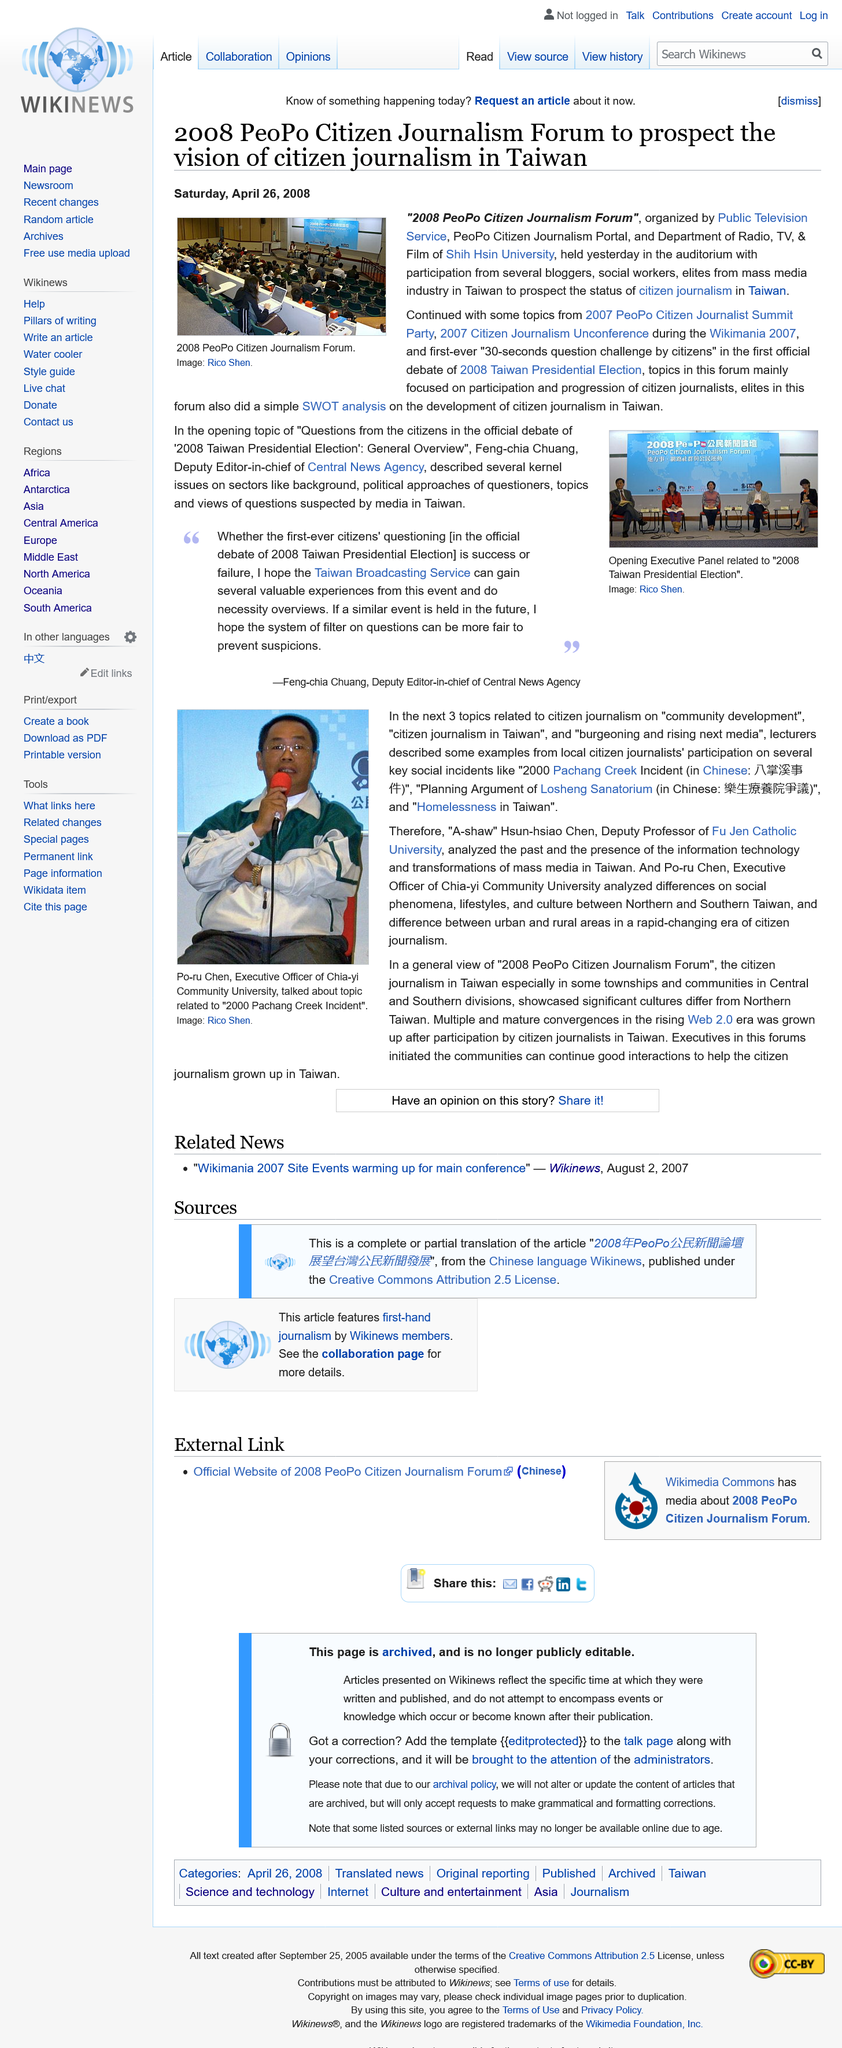Draw attention to some important aspects in this diagram. The executive officer of Chia-yi Community University is Po-ru Chen. The image was taken by Rico Shen. In 2008, the PeoPo Citizen Journalism Forum was organized by Public Television Service, PeoPo Citizen Journalism Portal, and the Department of Radio, TV & Film of Shih Hsin University. Feng-chia Chuang, the opening topic speaker in the "Questions from the citizens in the official debate of '2008 Taiwan Presidential Election' General Overview" at the 2008 PeoPo Citizen Journalism Forum, stated that... Po-ru Chen is holding a microphone in the image. 